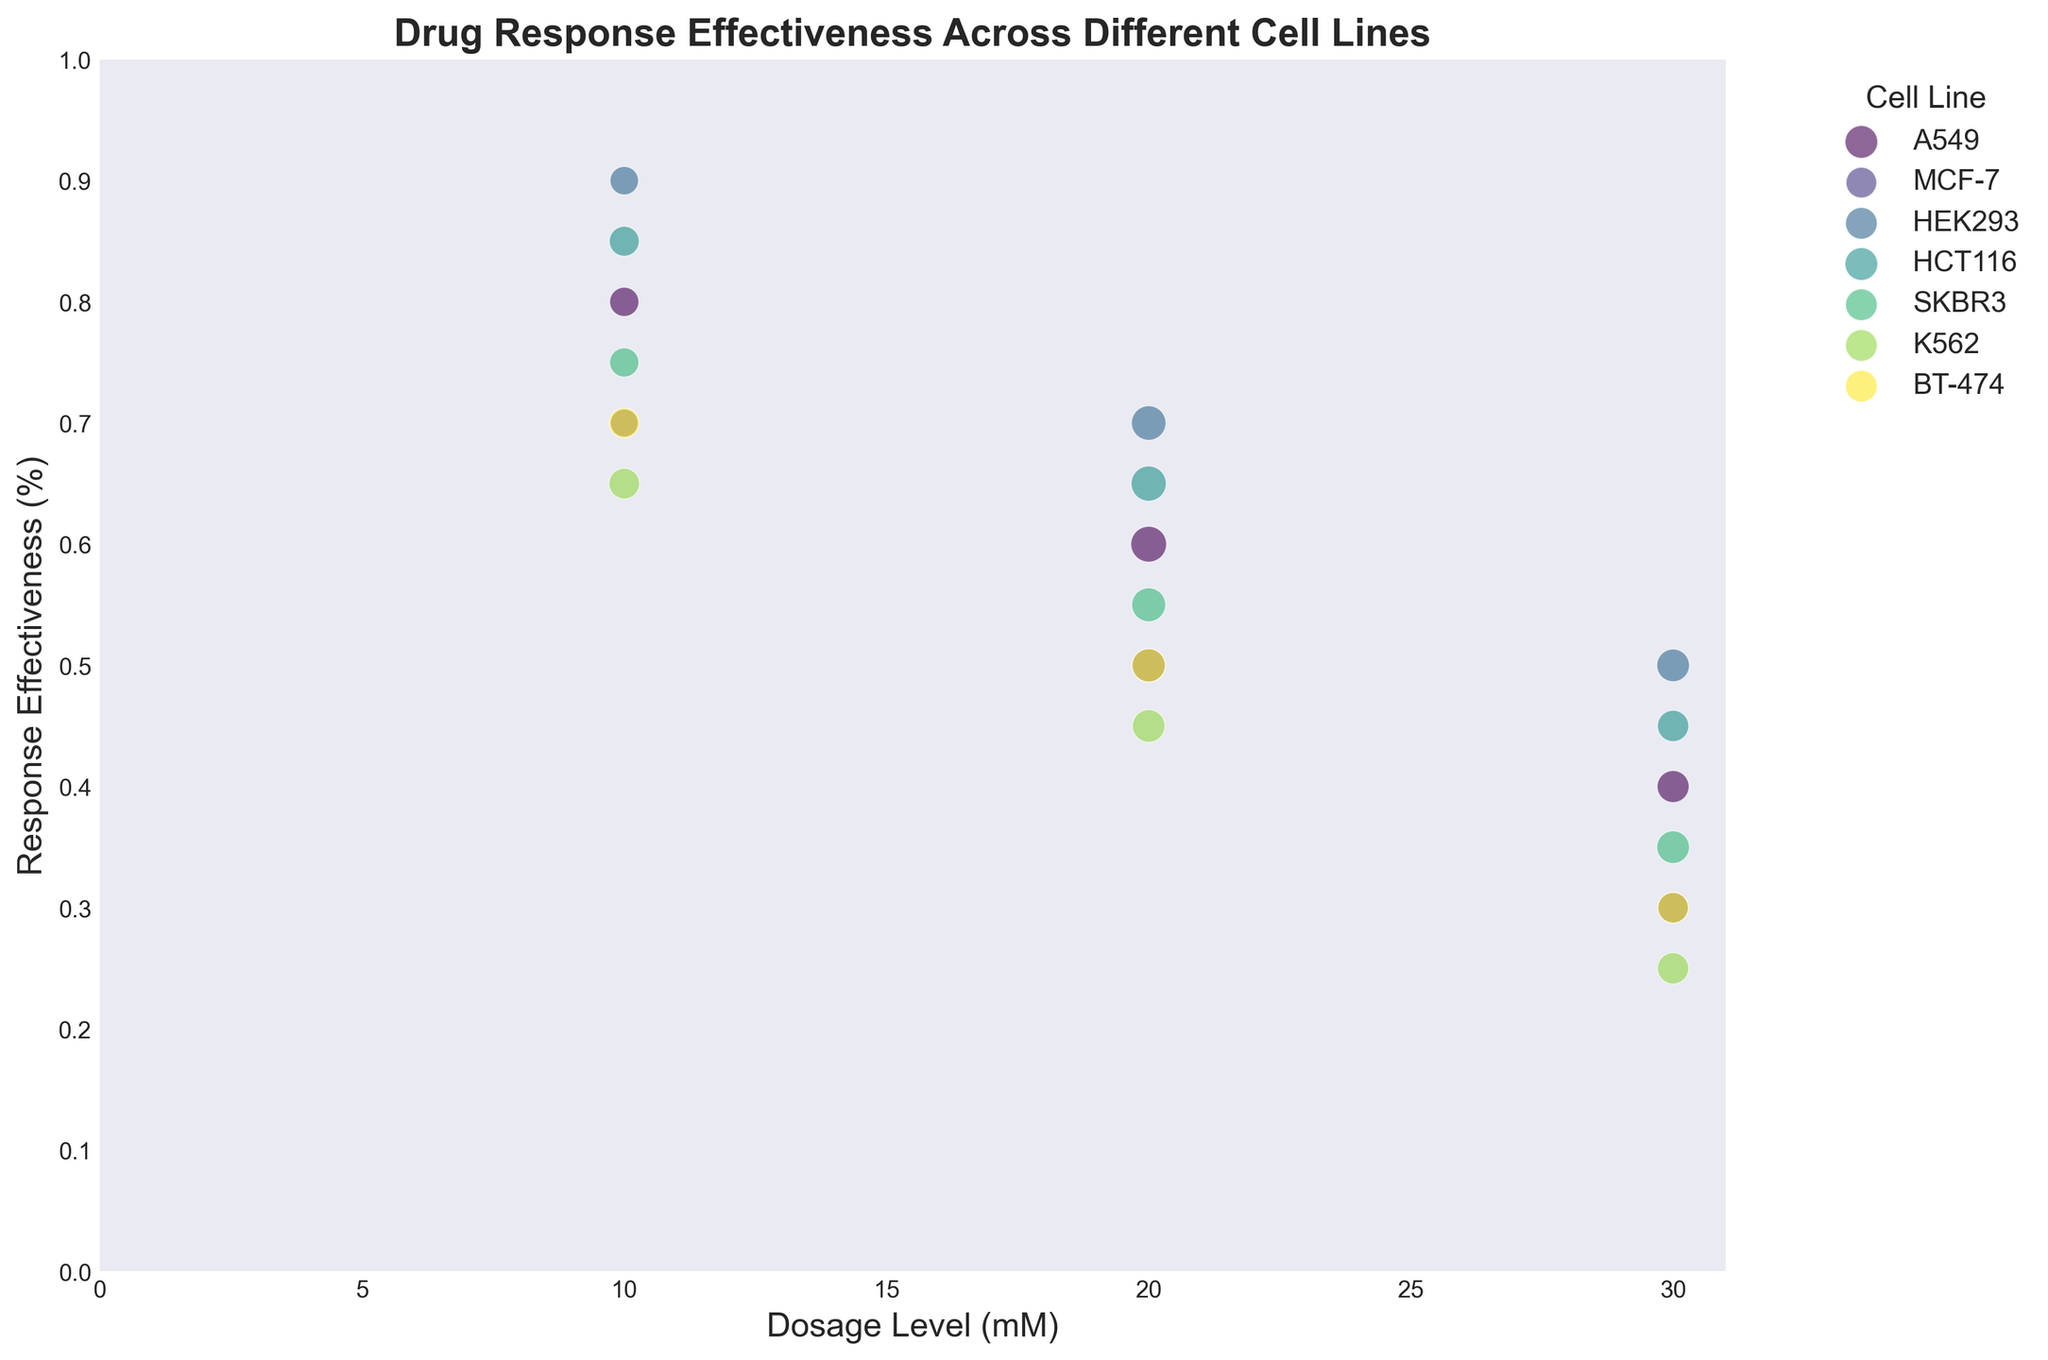Which cell line shows the highest response effectiveness at a dosage level of 10 mM? Find the dots aligned with 10 mM on the x-axis and identify the one with the highest y-value. In this case, HEK293 reaches 0.9, the highest.
Answer: HEK293 Which cell line shows the sharpest decline in response effectiveness as dosage increases from 10 mM to 30 mM? Compare the decrease in y-values from 10 mM to 30 mM for each cell line. K562 drops from 0.65 to 0.25, a 0.40 decline, the steepest among all.
Answer: K562 For cell line A549, what is the average response effectiveness across the three dosage levels? Add up the y-values for A549 at 10 mM, 20 mM, and 30 mM (0.8 + 0.6 + 0.4), then divide by 3. (0.8 + 0.6 + 0.4) / 3 = 0.6.
Answer: 0.6 Which cell line has the smallest bubble size at the dosage level of 20 mM? Look at the 20 mM column on the x-axis and identify the smallest bubble based on its size. K562 has the smallest bubble, indicating a cell count of 125, which is the smallest in the group.
Answer: K562 Which cell line shows a consistently linear decrease in response effectiveness as dosage increases? Check cell lines for a steady, roughly equal drop in y-values. Cell line HCT116 sees a uniform decline of 0.2 for each dosage increase.
Answer: HCT116 Comparing cell lines MCF-7 and SKBR3, which one has a greater response effectiveness at 20 mM? Locate the 20 mM x-axis points for MCF-7 and SKBR3 and compare their y-values. MCF-7 is at 0.5 and SKBR3 at 0.55, so SKBR3 is greater.
Answer: SKBR3 What is the total cell count represented by the bubbles for the cell line BT-474? Sum the cell counts for BT-474 at 10 mM, 20 mM, and 30 mM (105 + 130 + 110). 105 + 130 + 110 = 345.
Answer: 345 Which cell line's response effectiveness is closest to the average effectiveness across all lines at 10 mM? Calculate the average effectiveness at 10 mM for all lines ( (0.8+0.7+0.9+0.85+0.75+0.65+0.70) / 7 = 0.76), and find the closest effectiveness. SKBR3 at 0.75 is close to 0.76.
Answer: SKBR3 If you were to recommend a dosage for HCT116 to achieve an effectiveness higher than 0.5, which dosage would you choose? Look at HCT116's effectiveness at different dosages: 10 mM (0.85) and 20 mM (0.65) are both higher than 0.5. Choose the lowest dosage that meets the criteria.
Answer: 10 mM 